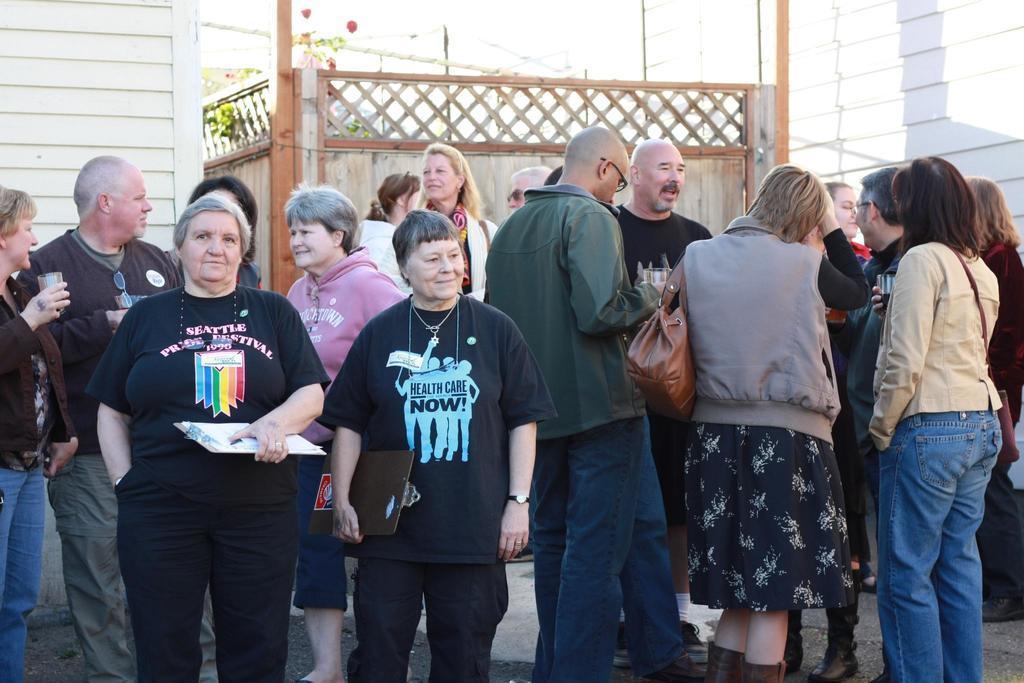In one or two sentences, can you explain what this image depicts? In this image in front there are people standing on the road. Behind them there are buildings and plants. 